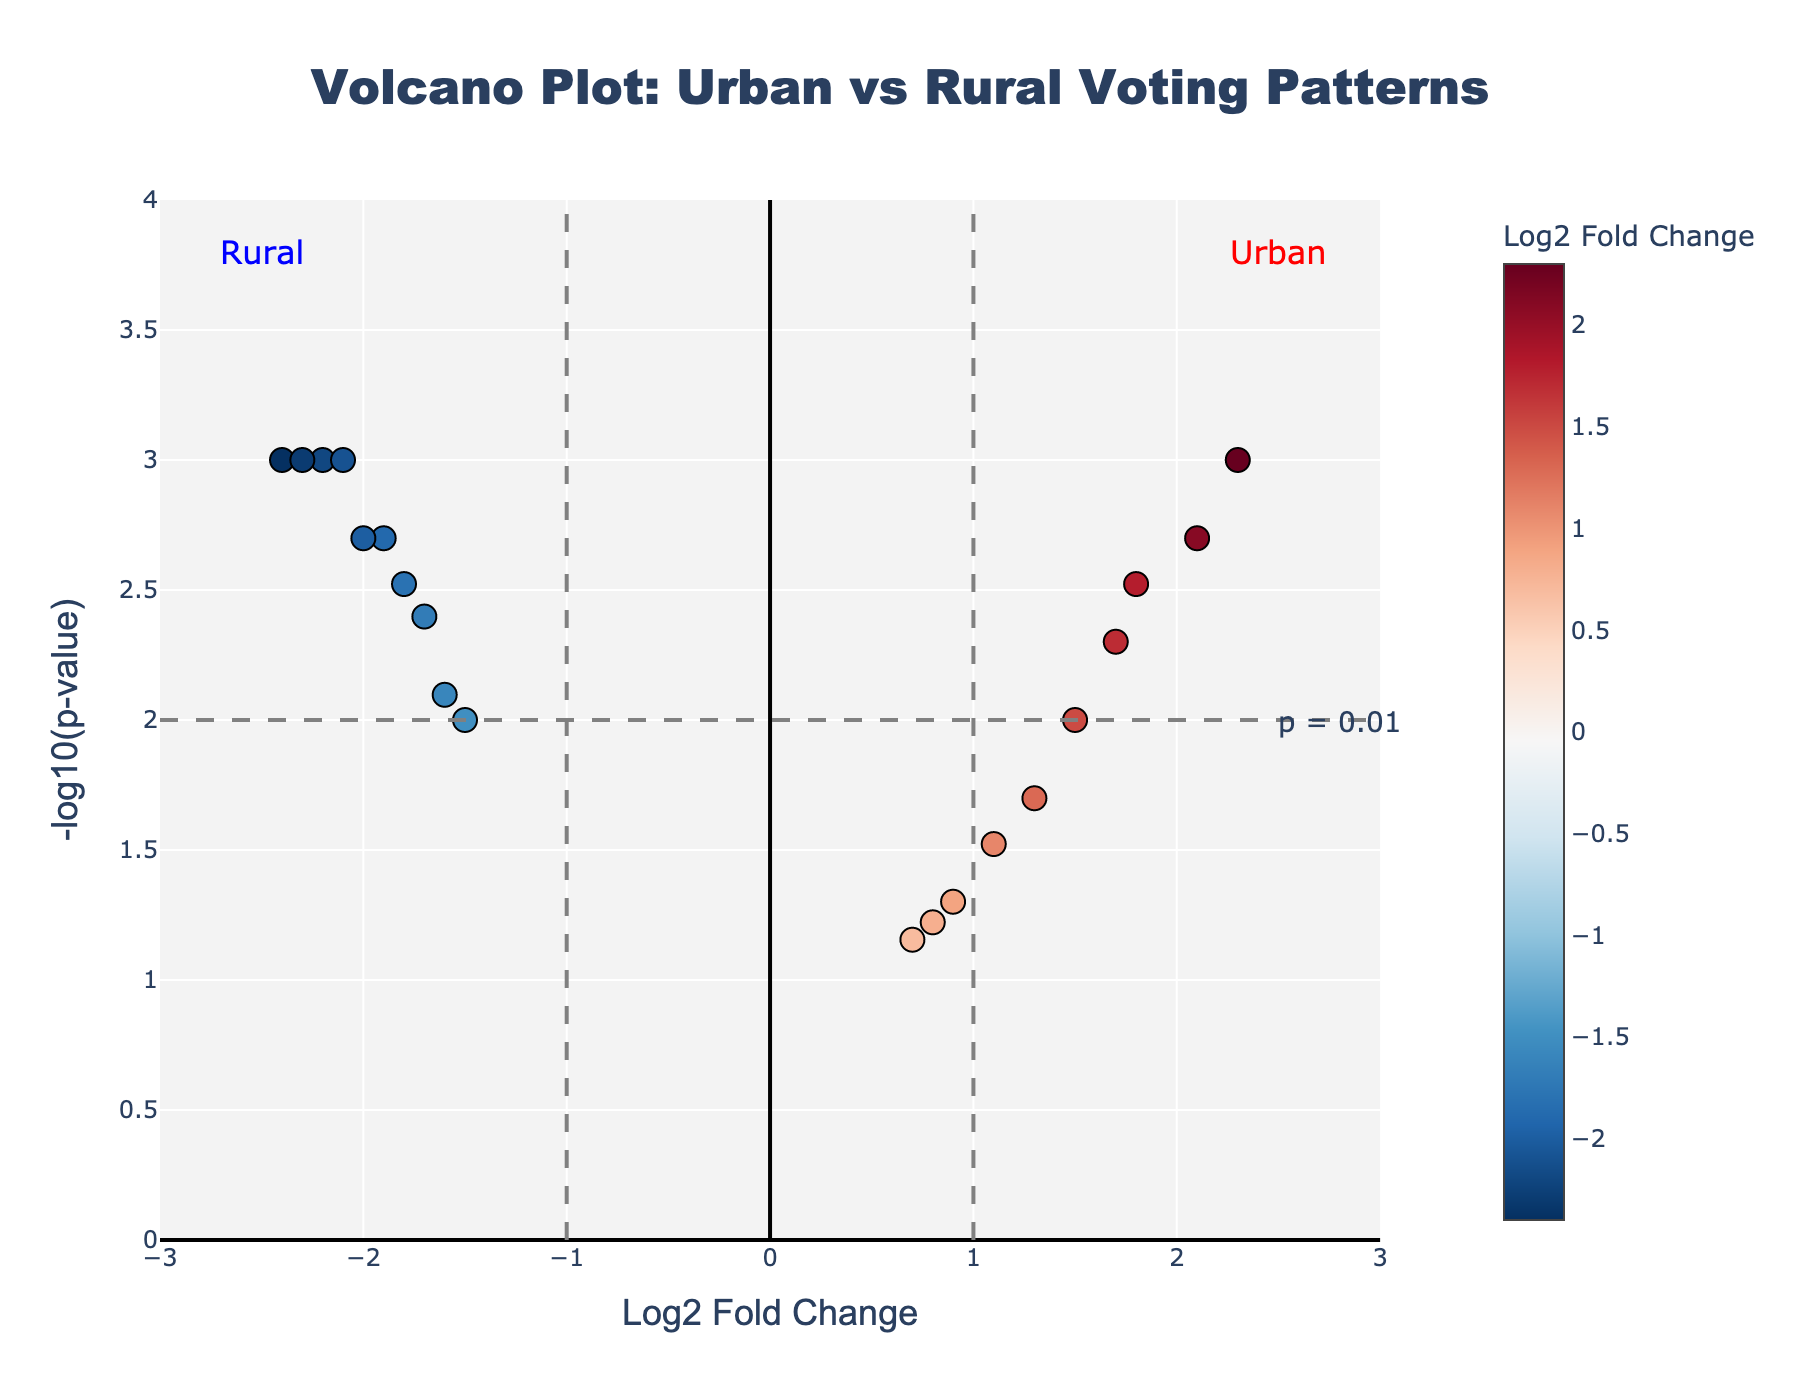How many regions have a Log2 Fold Change greater than 1? Look at the x-axis values for the regions and count the number of points with x-values greater than 1.
Answer: 7 Which rural region has the lowest p-value? Find the rural region with the highest point on the y-axis since -log10(p-value) is used.
Answer: Rural Montana What does the horizontal dashed grey line represent? The horizontal dashed line is positioned at -log10(p-value) of 2, indicating a p-value threshold of 0.01.
Answer: p = 0.01 threshold Which urban region has the highest Log2 Fold Change? Look at the regions on the right side of the x-axis (positive values) and identify the one with the highest x-value.
Answer: New York City Is there any region with a Log2 Fold Change between -1 and 1 and a p-value less than 0.01? Check the region points within the x-value range of -1 to 1 and above the y-value of 2 (p-value threshold of 0.01).
Answer: No How many regions have significant differential voting patterns based on the p-value threshold? Count all regions with a -log10(p-value) above 2 (y-value threshold indicating p < 0.01).
Answer: 14 Which regions are considered urban based on the annotations? The annotations at the top of the plot distinguish "Urban" and "Rural," locate the regions annotated as "Urban."
Answer: New York City, Los Angeles, Chicago, Philadelphia, San Jose Among the rural regions, which one has the highest negative Log2 Fold Change? Look at the left side of the x-axis (negative values) for rural regions, and find the lowest point along the x-axis.
Answer: Rural Montana What can be inferred about the voting pattern differences between urban and rural areas? Based on the positions of the data points and annotations, urban regions generally have positive Log2 Fold Changes, whereas rural regions have negative Log2 Fold Changes.
Answer: Urban areas lean more towards positive changes, rural areas lean more towards negative changes How does the addition of vertical dashed lines at Log2 Fold Change of -1 and 1 assist in the interpretation? The vertical lines at -1 and 1 help visually separate regions with significant fold changes (greater or less than 1), emphasizing the ones with higher differential voting patterns.
Answer: Emphasizes significant fold changes 